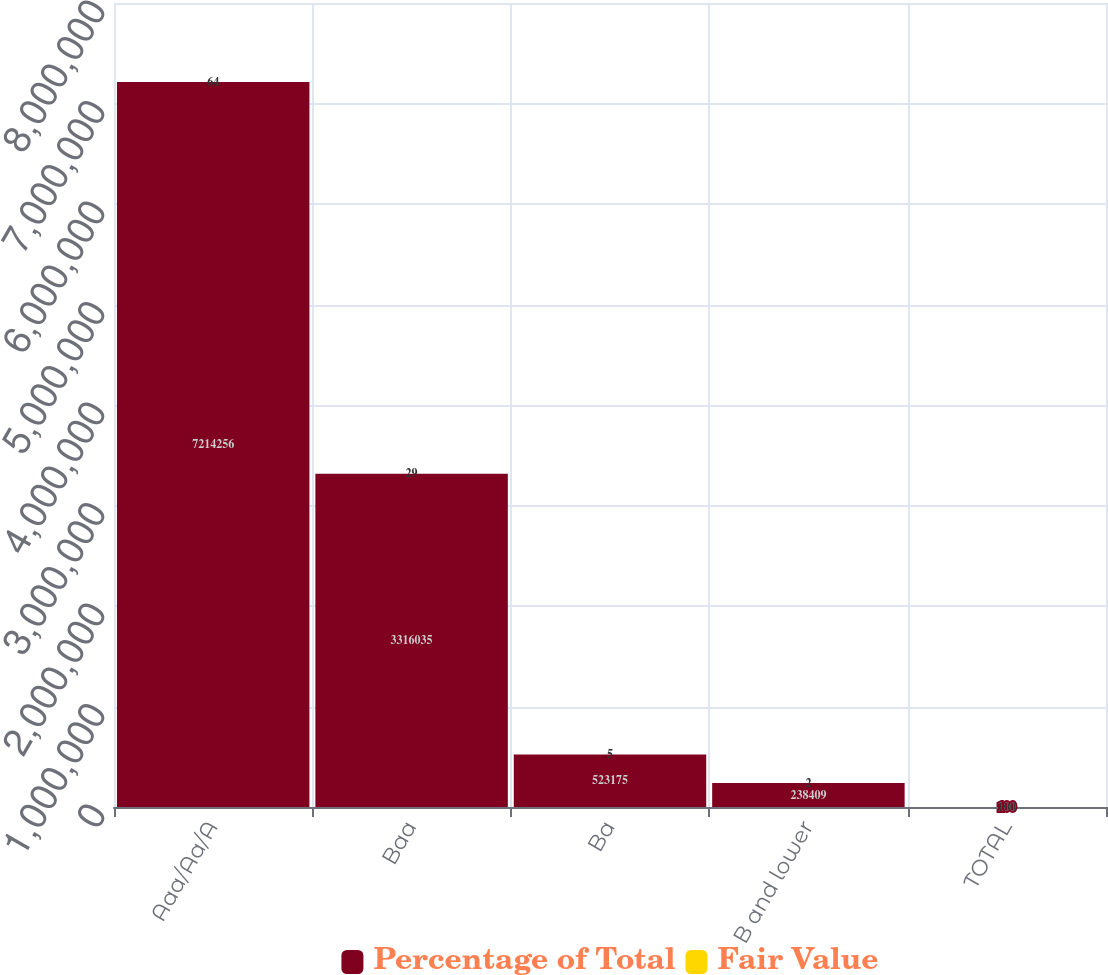Convert chart to OTSL. <chart><loc_0><loc_0><loc_500><loc_500><stacked_bar_chart><ecel><fcel>Aaa/Aa/A<fcel>Baa<fcel>Ba<fcel>B and lower<fcel>TOTAL<nl><fcel>Percentage of Total<fcel>7.21426e+06<fcel>3.31604e+06<fcel>523175<fcel>238409<fcel>100<nl><fcel>Fair Value<fcel>64<fcel>29<fcel>5<fcel>2<fcel>100<nl></chart> 